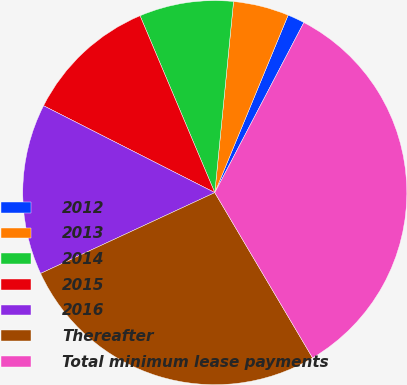<chart> <loc_0><loc_0><loc_500><loc_500><pie_chart><fcel>2012<fcel>2013<fcel>2014<fcel>2015<fcel>2016<fcel>Thereafter<fcel>Total minimum lease payments<nl><fcel>1.44%<fcel>4.68%<fcel>7.92%<fcel>11.16%<fcel>14.39%<fcel>26.59%<fcel>33.82%<nl></chart> 